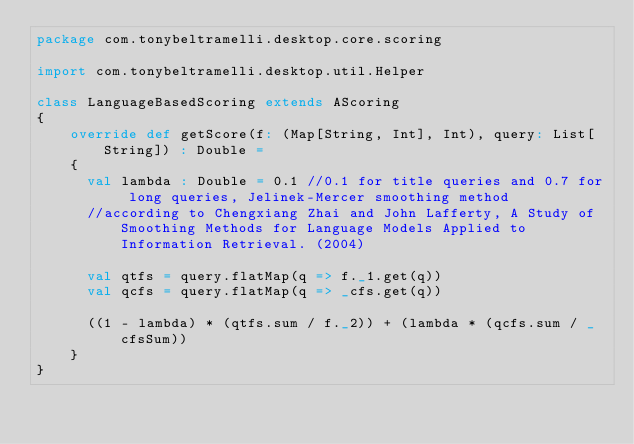<code> <loc_0><loc_0><loc_500><loc_500><_Scala_>package com.tonybeltramelli.desktop.core.scoring

import com.tonybeltramelli.desktop.util.Helper

class LanguageBasedScoring extends AScoring
{  
	override def getScore(f: (Map[String, Int], Int), query: List[String]) : Double =
	{
	  val lambda : Double = 0.1 //0.1 for title queries and 0.7 for long queries, Jelinek-Mercer smoothing method 
	  //according to Chengxiang Zhai and John Lafferty, A Study of Smoothing Methods for Language Models Applied to Information Retrieval. (2004)

	  val qtfs = query.flatMap(q => f._1.get(q))
	  val qcfs = query.flatMap(q => _cfs.get(q))
	  
	  ((1 - lambda) * (qtfs.sum / f._2)) + (lambda * (qcfs.sum / _cfsSum))
    }
}</code> 